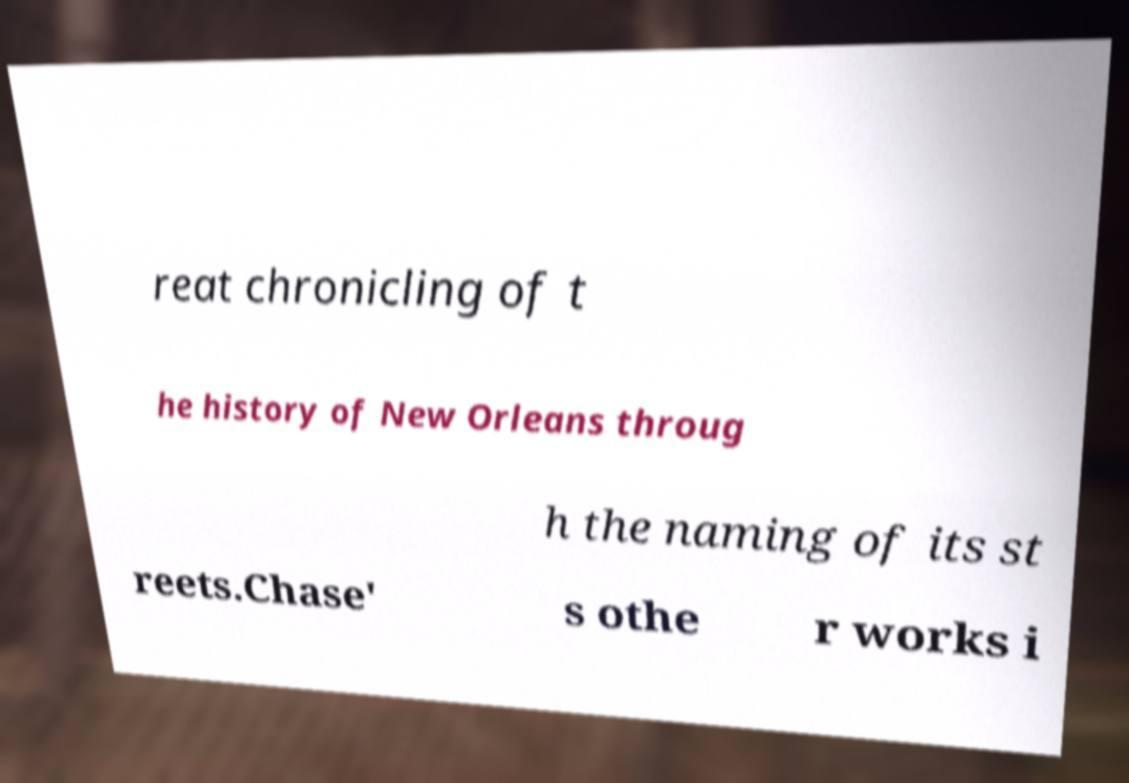I need the written content from this picture converted into text. Can you do that? reat chronicling of t he history of New Orleans throug h the naming of its st reets.Chase' s othe r works i 